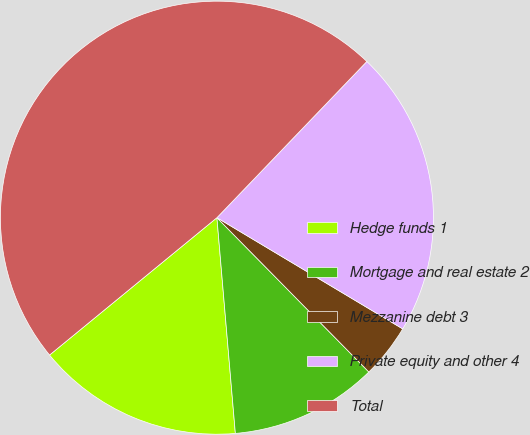Convert chart. <chart><loc_0><loc_0><loc_500><loc_500><pie_chart><fcel>Hedge funds 1<fcel>Mortgage and real estate 2<fcel>Mezzanine debt 3<fcel>Private equity and other 4<fcel>Total<nl><fcel>15.42%<fcel>11.02%<fcel>4.04%<fcel>21.41%<fcel>48.11%<nl></chart> 